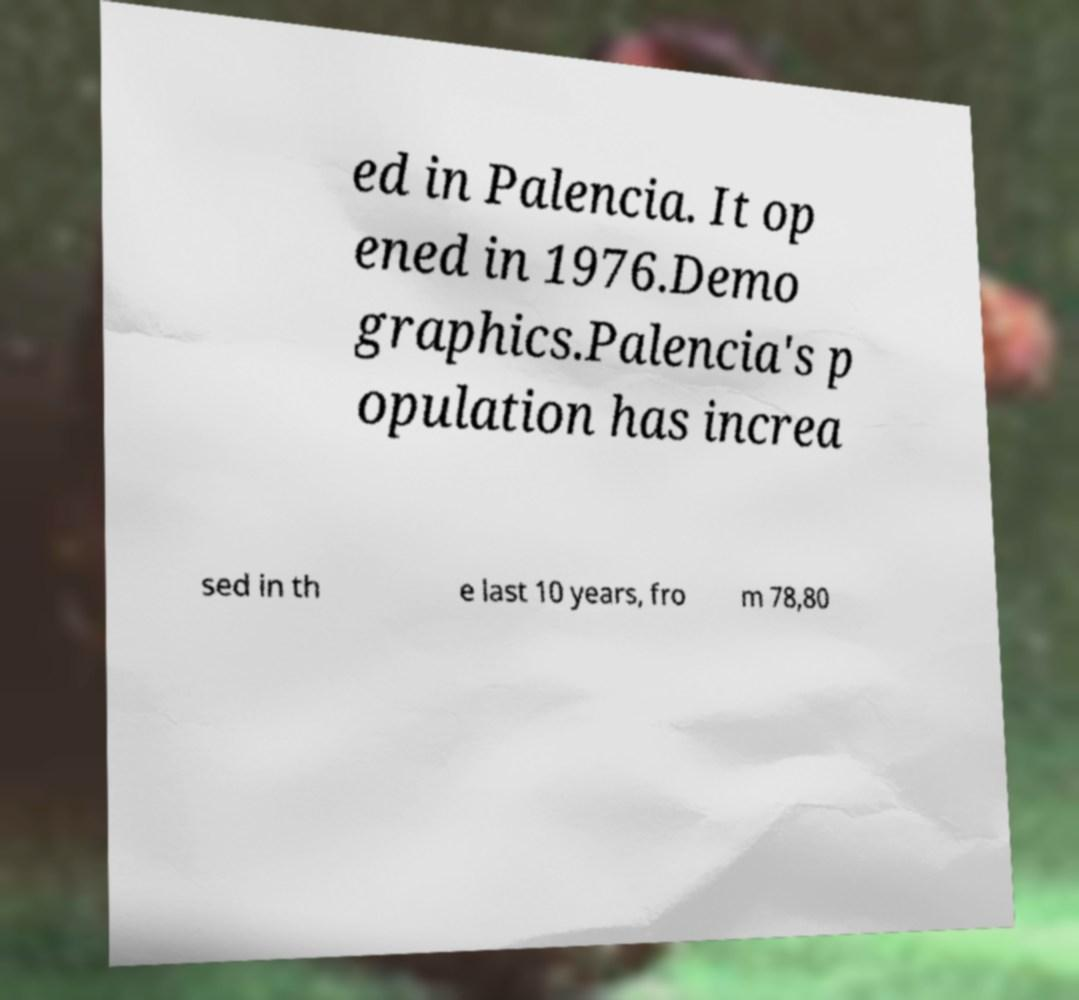Can you read and provide the text displayed in the image?This photo seems to have some interesting text. Can you extract and type it out for me? ed in Palencia. It op ened in 1976.Demo graphics.Palencia's p opulation has increa sed in th e last 10 years, fro m 78,80 